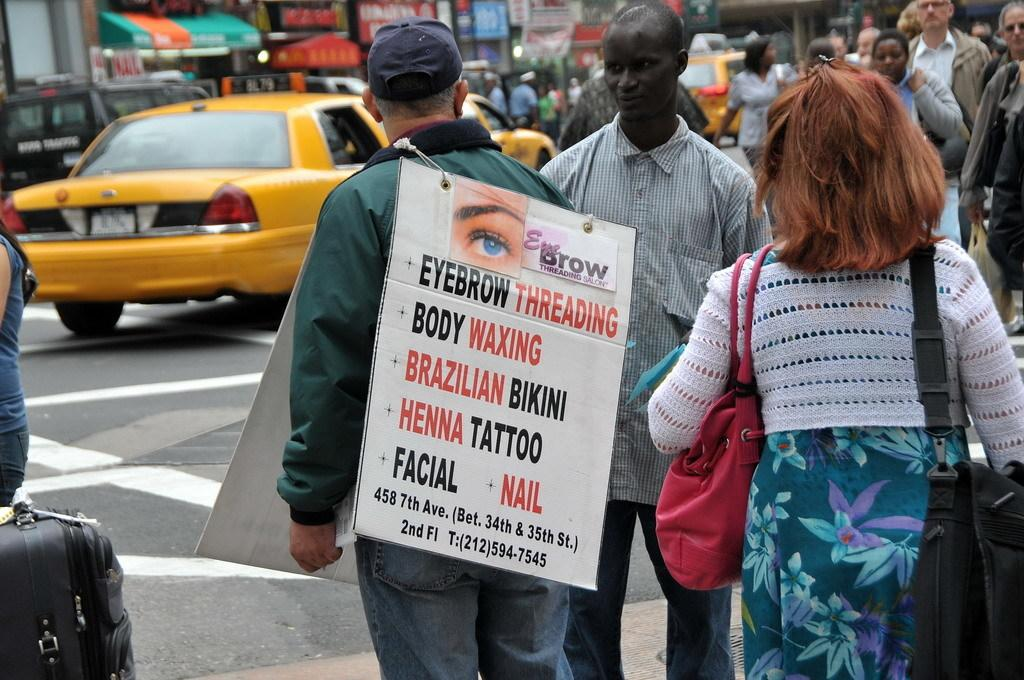<image>
Provide a brief description of the given image. Someone wears a sandwich board advertising eyebrow threading and body waxing. 